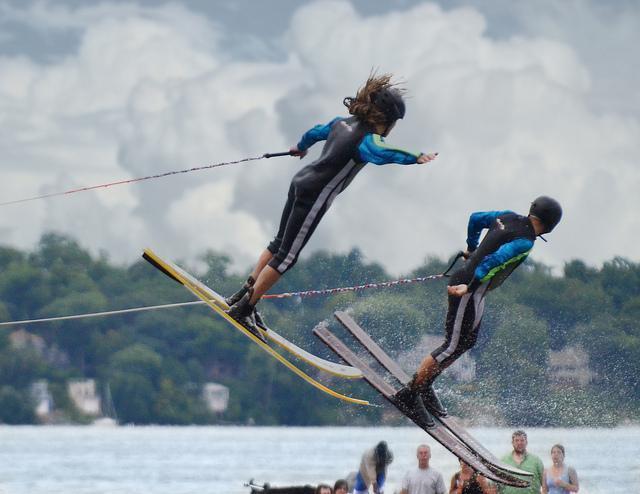How many ski can be seen?
Give a very brief answer. 2. How many people are visible?
Give a very brief answer. 2. How many ears does the elephant have?
Give a very brief answer. 0. 